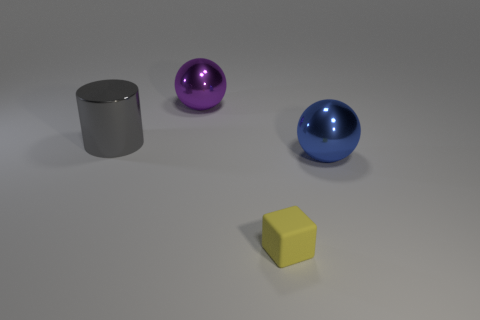Add 4 big purple shiny things. How many objects exist? 8 Subtract 1 blocks. How many blocks are left? 0 Subtract all cylinders. How many objects are left? 3 Subtract all brown spheres. Subtract all blue cylinders. How many spheres are left? 2 Subtract all big metallic cylinders. Subtract all small yellow rubber cubes. How many objects are left? 2 Add 2 yellow blocks. How many yellow blocks are left? 3 Add 1 small cyan balls. How many small cyan balls exist? 1 Subtract 0 green cylinders. How many objects are left? 4 